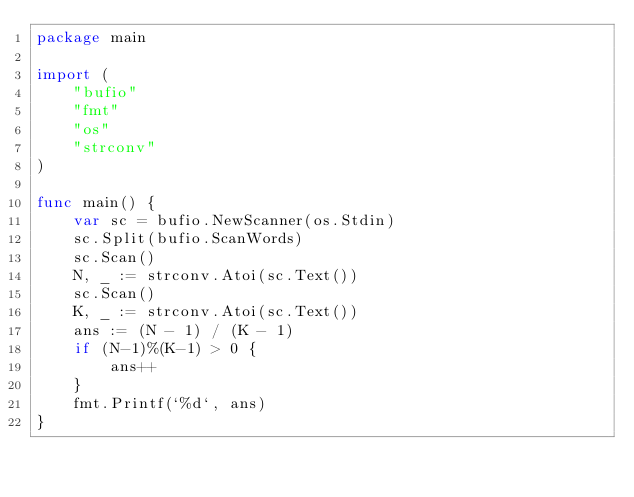<code> <loc_0><loc_0><loc_500><loc_500><_Go_>package main

import (
	"bufio"
	"fmt"
	"os"
	"strconv"
)

func main() {
	var sc = bufio.NewScanner(os.Stdin)
	sc.Split(bufio.ScanWords)
	sc.Scan()
	N, _ := strconv.Atoi(sc.Text())
	sc.Scan()
	K, _ := strconv.Atoi(sc.Text())
	ans := (N - 1) / (K - 1)
	if (N-1)%(K-1) > 0 {
		ans++
	}
	fmt.Printf(`%d`, ans)
}
</code> 